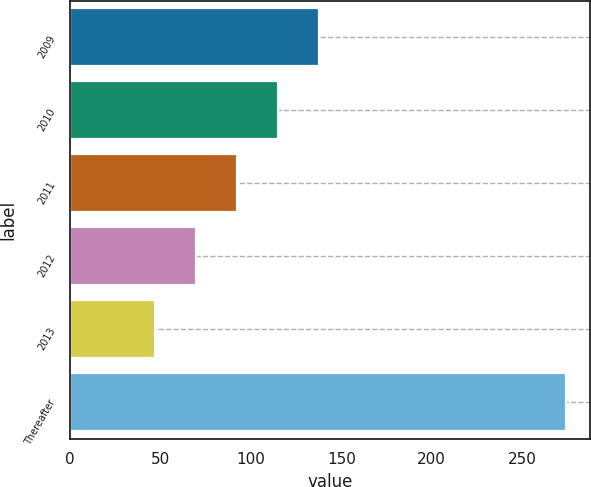<chart> <loc_0><loc_0><loc_500><loc_500><bar_chart><fcel>2009<fcel>2010<fcel>2011<fcel>2012<fcel>2013<fcel>Thereafter<nl><fcel>137.8<fcel>115.1<fcel>92.4<fcel>69.7<fcel>47<fcel>274<nl></chart> 